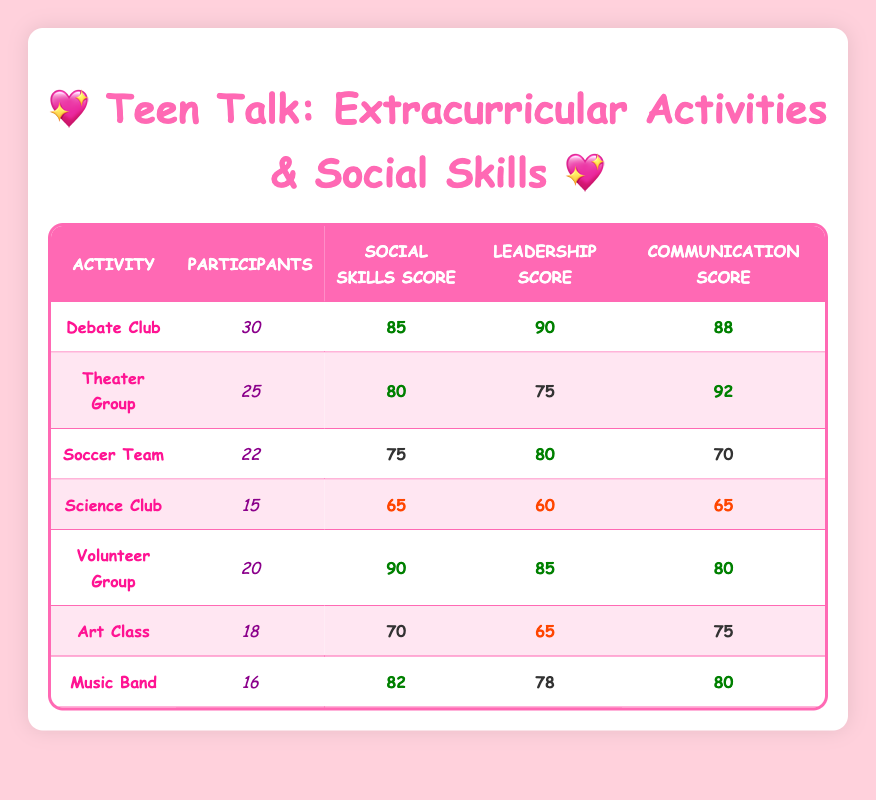What is the social skills score for the Debate Club? The table clearly shows that the social skills score for the Debate Club is 85.
Answer: 85 How many participants are in the Theater Group? According to the table, the Theater Group has 25 participants listed.
Answer: 25 Which extracurricular activity has the highest communication score? By examining the table, the Theater Group has the highest communication score of 92.
Answer: Theater Group What is the average social skills score across all activities? First, add the social skills scores: 85 + 80 + 75 + 65 + 90 + 70 + 82 = 547. Then divide by the number of activities, which is 7: 547 / 7 = 78.14, rounded to 78 when taking an integer.
Answer: 78 Is the social skills score for the Volunteer Group higher than that of the Soccer Team? The Volunteer Group scored 90 in social skills while the Soccer Team scored 75, so yes, the Volunteer Group has a higher score.
Answer: Yes How many extracurricular activities have a social skills score below 80? From the table, the activities with scores below 80 are the Science Club (65) and the Soccer Team (75), making it 2 activities total.
Answer: 2 What is the difference between the highest and lowest leadership scores in the table? The highest leadership score is from Debate Club, which is 90, and the lowest is from the Science Club at 60. The difference is 90 - 60 = 30.
Answer: 30 Which activity has the lowest communication score and what is that score? The activity with the lowest communication score is the Soccer Team, which has a score of 70.
Answer: Soccer Team, 70 What combination of activities yields the highest total for leadership scores when combined? Summing the leadership scores of Debate Club (90), Volunteer Group (85), and Music Band (78) gives the highest total of 253. Other combinations yield lower totals.
Answer: 253 